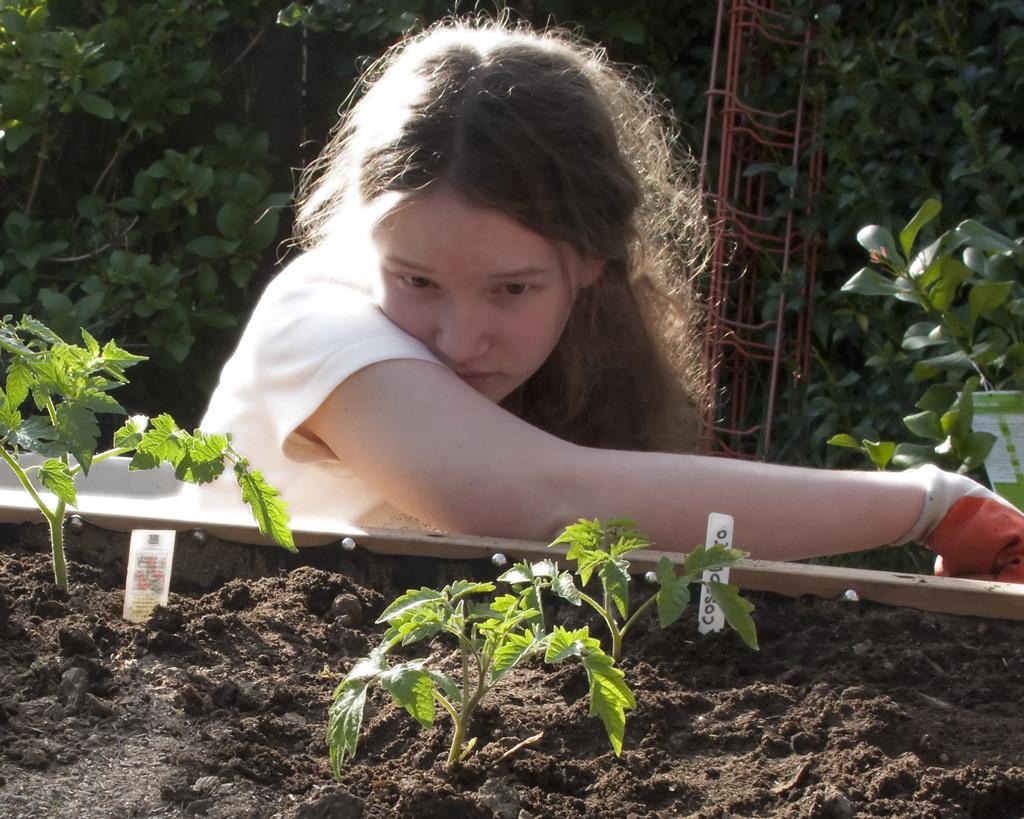Who is the main subject in the image? There is a woman in the image. What is the woman wearing on her hand? The woman is wearing a glove. What can be seen in front of the woman? There are plants in front of the woman. What type of objects can be seen in the background of the image? There are metal rods visible in the background of the image. How does the woman express her anger in the image? There is no indication of anger in the image, and the woman's emotions cannot be determined from the provided facts. 